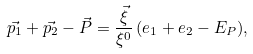<formula> <loc_0><loc_0><loc_500><loc_500>\vec { p _ { 1 } } + \vec { p _ { 2 } } - \vec { P } = \frac { \vec { \xi } } { \xi ^ { 0 } } \, ( e _ { 1 } + e _ { 2 } - E _ { P } ) ,</formula> 